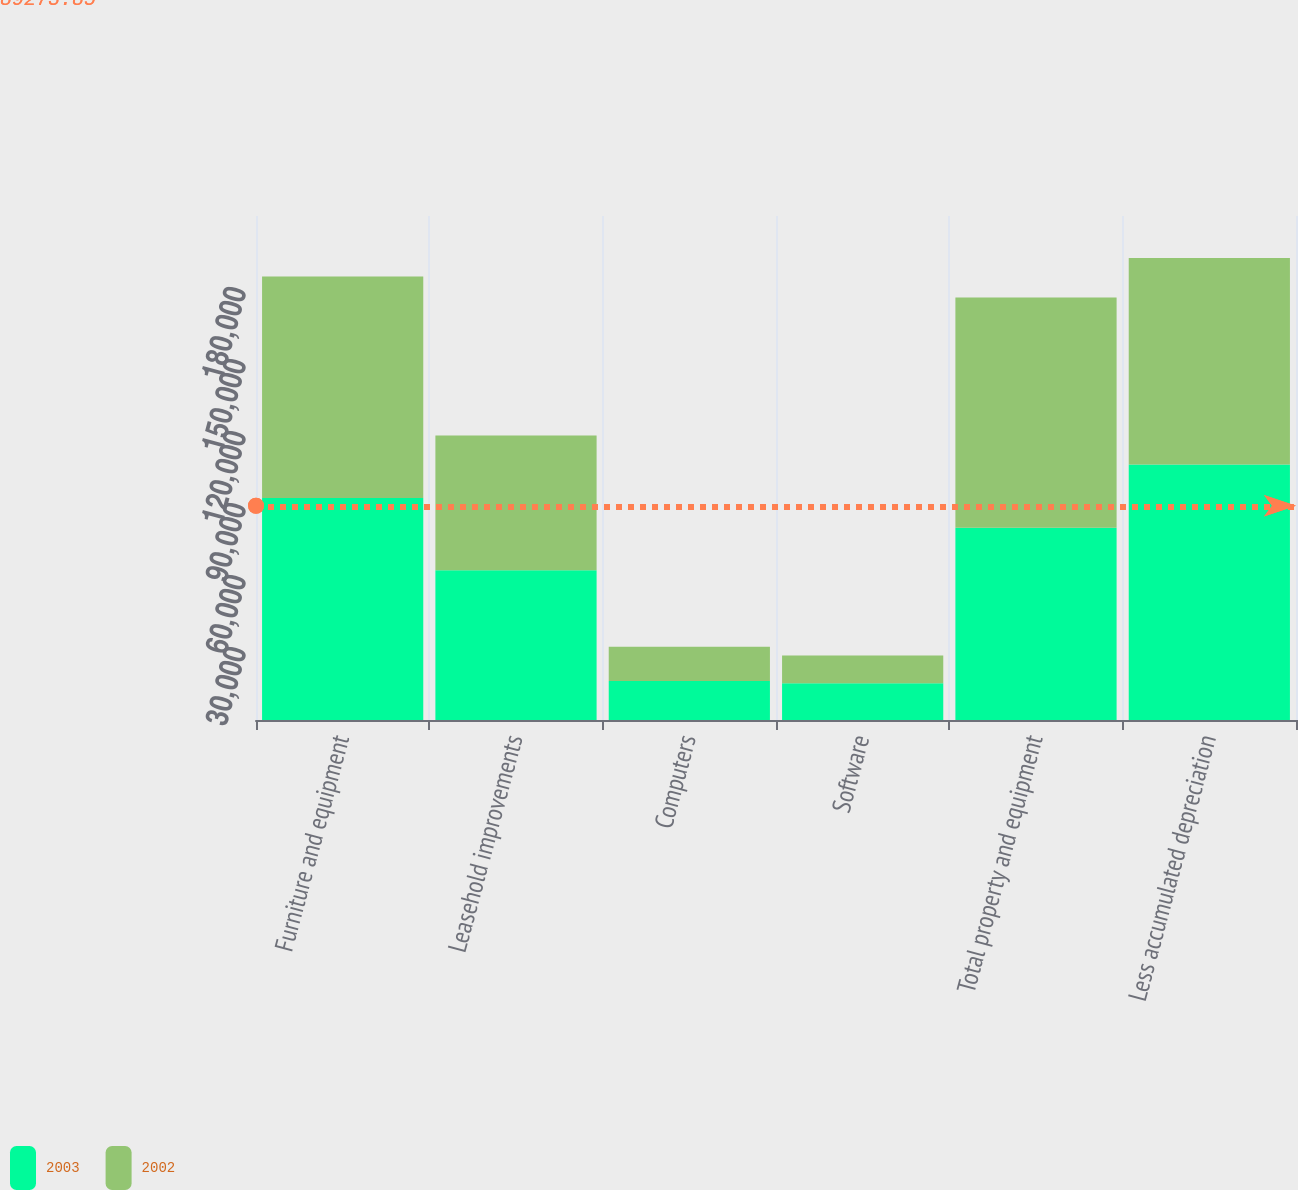Convert chart. <chart><loc_0><loc_0><loc_500><loc_500><stacked_bar_chart><ecel><fcel>Furniture and equipment<fcel>Leasehold improvements<fcel>Computers<fcel>Software<fcel>Total property and equipment<fcel>Less accumulated depreciation<nl><fcel>2003<fcel>92497<fcel>62412<fcel>16289<fcel>15336<fcel>80083<fcel>106451<nl><fcel>2002<fcel>92330<fcel>56177<fcel>14271<fcel>11564<fcel>95991<fcel>86003<nl></chart> 